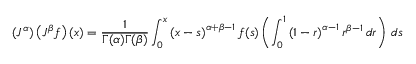<formula> <loc_0><loc_0><loc_500><loc_500>\left ( J ^ { \alpha } \right ) \left ( J ^ { \beta } f \right ) ( x ) = { \frac { 1 } { \Gamma ( \alpha ) \Gamma ( \beta ) } } \int _ { 0 } ^ { x } \left ( x - s \right ) ^ { \alpha + \beta - 1 } f ( s ) \left ( \int _ { 0 } ^ { 1 } \left ( 1 - r \right ) ^ { \alpha - 1 } r ^ { \beta - 1 } \, d r \right ) \, d s</formula> 